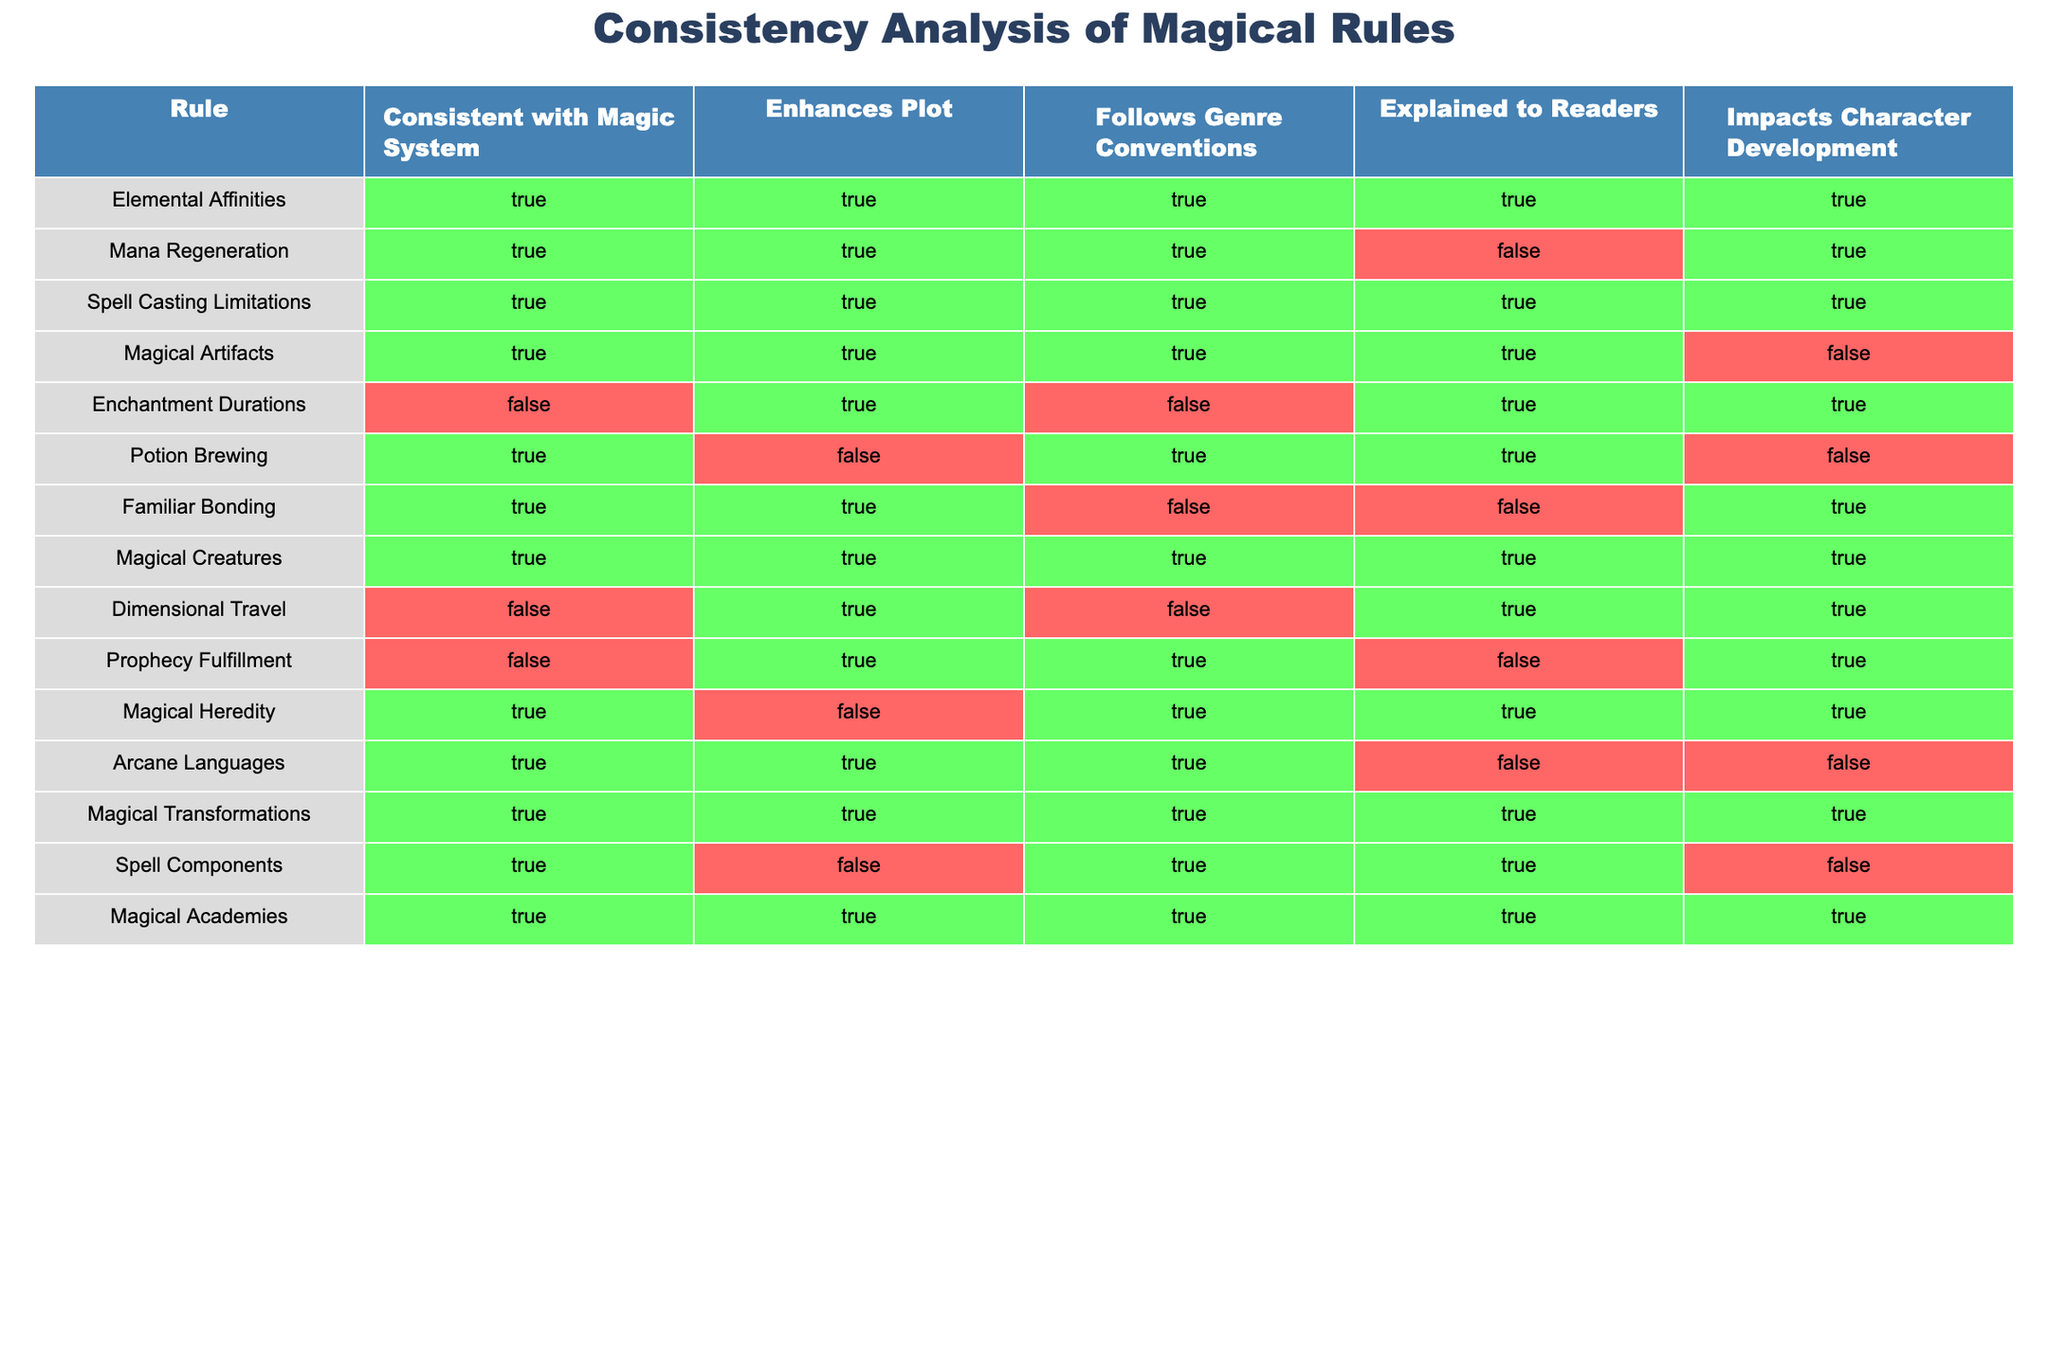What is the consistency status of "Mana Regeneration"? In the table under the "Consistent with Magic System" column, "Mana Regeneration" is marked as TRUE, indicating that this rule aligns with the established magical system rules.
Answer: TRUE How many rules enhance the plot? By scanning the "Enhances Plot" column, we count the number of TRUE entries. The rules that enhance the plot are: Elemental Affinities, Mana Regeneration, Spell Casting Limitations, Enchantment Durations, Magical Creatures, Magical Transformations, and Magical Academies, totaling 7 rules.
Answer: 7 Is "Potion Brewing" explained to readers? Looking at the "Explained to Readers" column for "Potion Brewing", it is marked as FALSE, showing that this rule is not sufficiently explained to the audience.
Answer: FALSE How many magical rules do not impact character development? We can identify the rules that have FALSE under the "Impacts Character Development" column. These rules include Mana Regeneration, Magical Artifacts, Potion Brewing, Familiar Bonding, Arcane Languages, and Spell Components, giving a total of 6 rules that do not impact character development.
Answer: 6 Which magical rule has the lowest consistency with the magic system? By analyzing the "Consistent with Magic System" column, the rules Enchantment Durations, Dimensional Travel, and Prophecy Fulfillment are marked FALSE. The first rule in this list is "Enchantment Durations," indicating the lowest consistency with the magic system.
Answer: Enchantment Durations Are there more rules that enhance the plot than those that follow genre conventions? By counting the TRUE entries, we found that 7 rules enhance the plot, while only 6 rules follow genre conventions when reviewing the corresponding columns. Since 7 is greater than 6, there are more rules that enhance the plot.
Answer: Yes What percentage of rules are explained to readers? To find the percentage, count the number of TRUE entries (6 rules) in the "Explained to Readers" column. Since there are 14 total rules, the percentage is (6/14) * 100, resulting in approximately 42.86%.
Answer: 42.86% How many magical rules related to characters are also consistent with the magic system? We look for the TRUE entries in the "Consistent with Magic System" column and additionally check the "Impacts Character Development" column. The rules that meet both criteria are Elemental Affinities, Spell Casting Limitations, Magical Creatures, Magical Heredity, and Magical Transformations. This gives us a total of 5 rules that are both related to characters and consistent with the magic system.
Answer: 5 Which rule is the most consistent with the magic system? The rule with the highest consistency is "Elemental Affinities," which is marked TRUE in all columns, illustrating its strong alignment and importance in the magical framework.
Answer: Elemental Affinities 